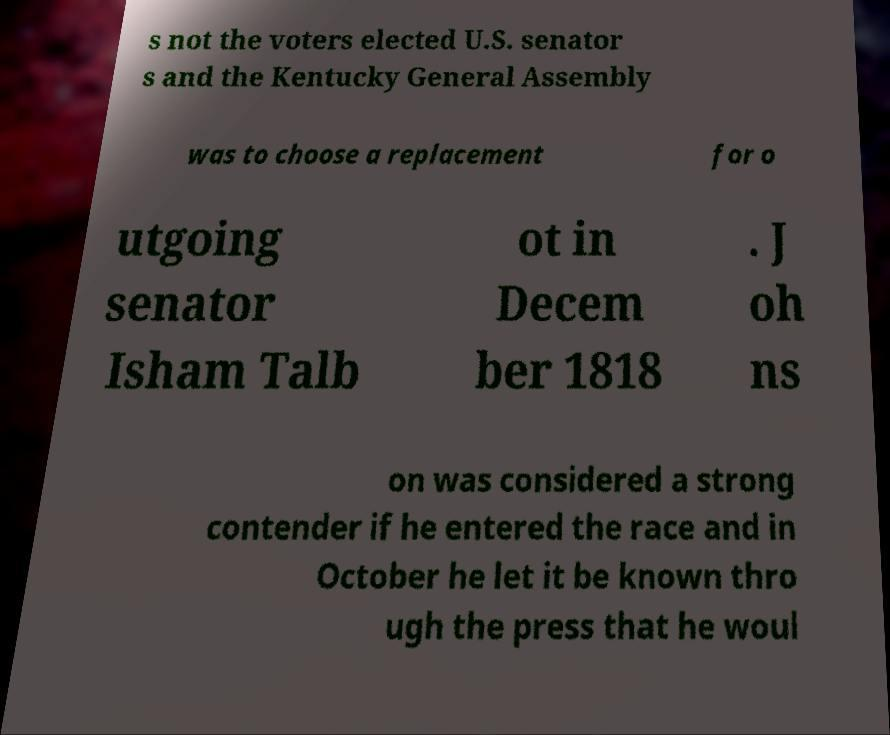What messages or text are displayed in this image? I need them in a readable, typed format. s not the voters elected U.S. senator s and the Kentucky General Assembly was to choose a replacement for o utgoing senator Isham Talb ot in Decem ber 1818 . J oh ns on was considered a strong contender if he entered the race and in October he let it be known thro ugh the press that he woul 